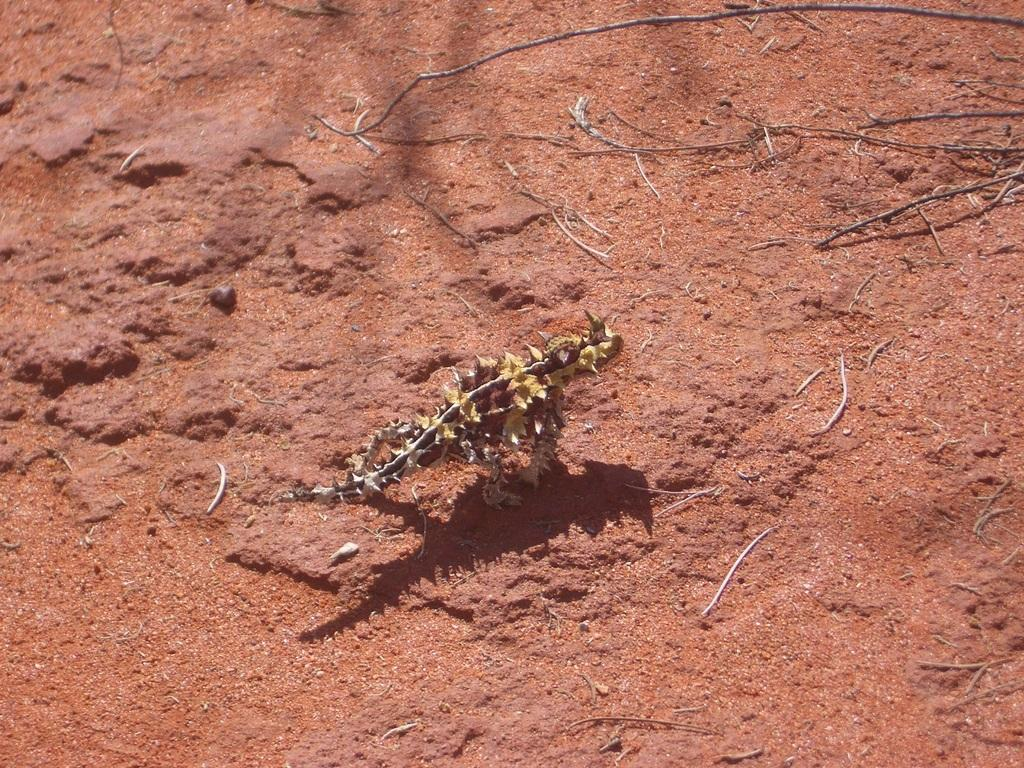What type of animal is in the image? There is a small reptile in the image. What is the reptile standing on? The reptile is on red sand. Where are the wooden sticks located in the image? The wooden sticks are in the top right corner of the image. How many fangs can be seen on the reptile in the image? There are no fangs visible on the reptile in the image, as reptiles typically do not have fangs. 